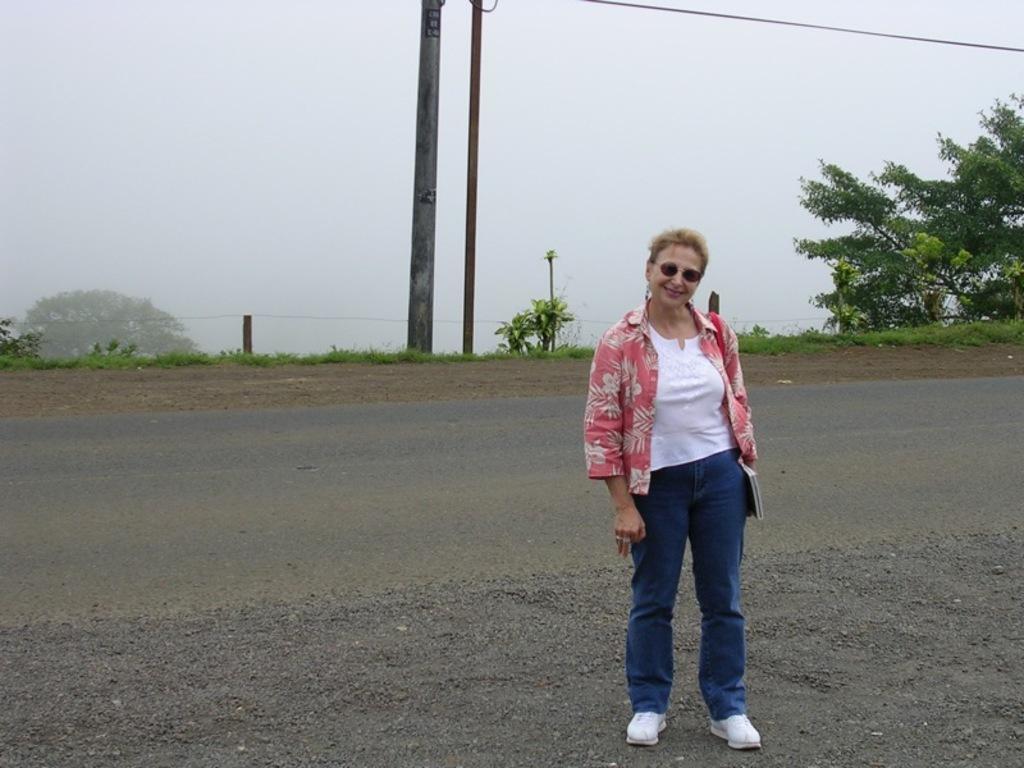How would you summarize this image in a sentence or two? In this image we can see a woman standing on the ground. We can also see some poles, a wire, some plants, trees and the sky. 